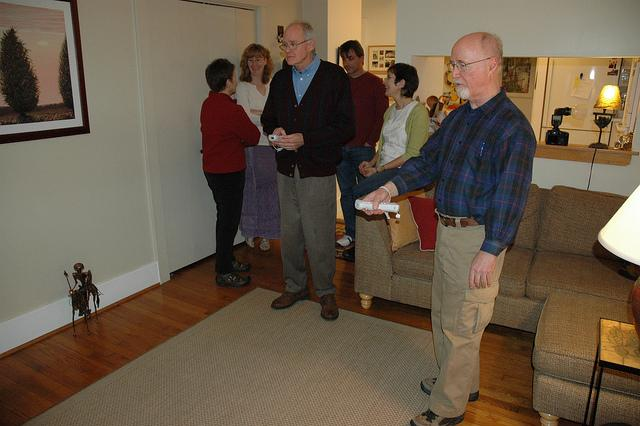Where have these people gathered? Please explain your reasoning. home. There is a visible sitting area with couches that are normally found in the house. 